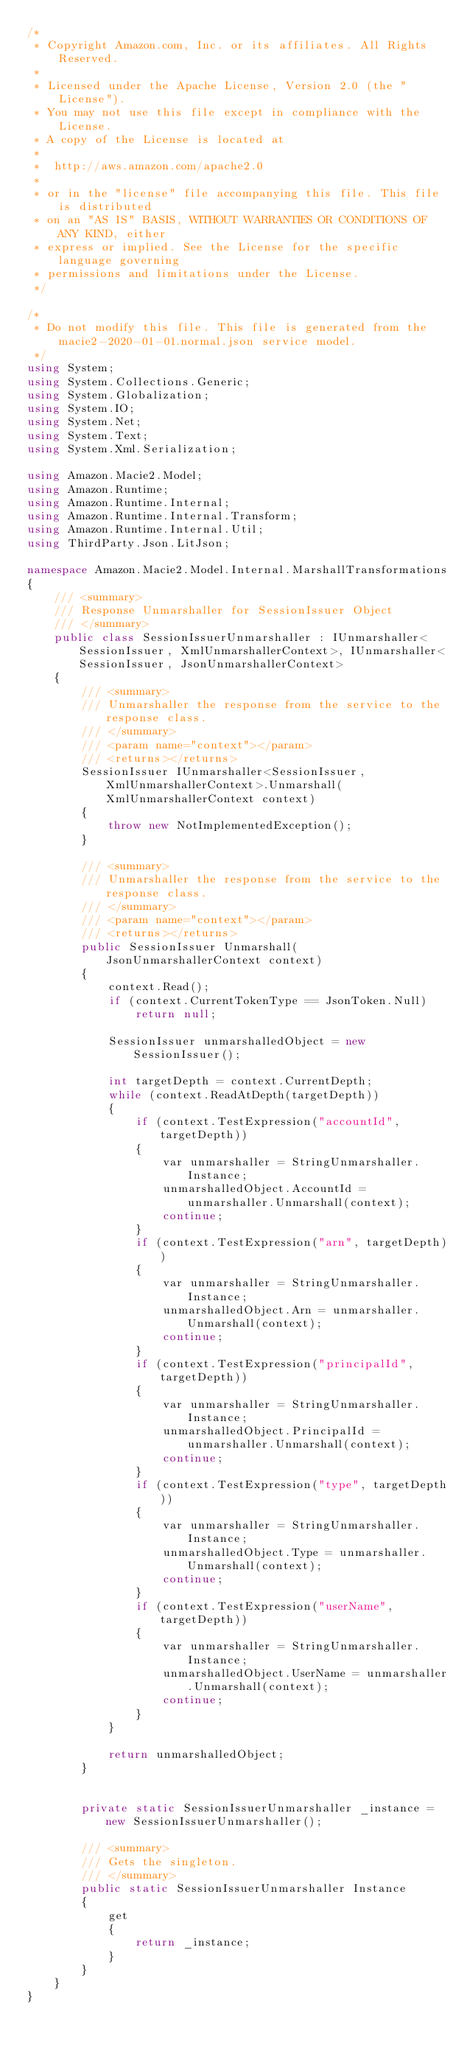<code> <loc_0><loc_0><loc_500><loc_500><_C#_>/*
 * Copyright Amazon.com, Inc. or its affiliates. All Rights Reserved.
 * 
 * Licensed under the Apache License, Version 2.0 (the "License").
 * You may not use this file except in compliance with the License.
 * A copy of the License is located at
 * 
 *  http://aws.amazon.com/apache2.0
 * 
 * or in the "license" file accompanying this file. This file is distributed
 * on an "AS IS" BASIS, WITHOUT WARRANTIES OR CONDITIONS OF ANY KIND, either
 * express or implied. See the License for the specific language governing
 * permissions and limitations under the License.
 */

/*
 * Do not modify this file. This file is generated from the macie2-2020-01-01.normal.json service model.
 */
using System;
using System.Collections.Generic;
using System.Globalization;
using System.IO;
using System.Net;
using System.Text;
using System.Xml.Serialization;

using Amazon.Macie2.Model;
using Amazon.Runtime;
using Amazon.Runtime.Internal;
using Amazon.Runtime.Internal.Transform;
using Amazon.Runtime.Internal.Util;
using ThirdParty.Json.LitJson;

namespace Amazon.Macie2.Model.Internal.MarshallTransformations
{
    /// <summary>
    /// Response Unmarshaller for SessionIssuer Object
    /// </summary>  
    public class SessionIssuerUnmarshaller : IUnmarshaller<SessionIssuer, XmlUnmarshallerContext>, IUnmarshaller<SessionIssuer, JsonUnmarshallerContext>
    {
        /// <summary>
        /// Unmarshaller the response from the service to the response class.
        /// </summary>  
        /// <param name="context"></param>
        /// <returns></returns>
        SessionIssuer IUnmarshaller<SessionIssuer, XmlUnmarshallerContext>.Unmarshall(XmlUnmarshallerContext context)
        {
            throw new NotImplementedException();
        }

        /// <summary>
        /// Unmarshaller the response from the service to the response class.
        /// </summary>  
        /// <param name="context"></param>
        /// <returns></returns>
        public SessionIssuer Unmarshall(JsonUnmarshallerContext context)
        {
            context.Read();
            if (context.CurrentTokenType == JsonToken.Null) 
                return null;

            SessionIssuer unmarshalledObject = new SessionIssuer();
        
            int targetDepth = context.CurrentDepth;
            while (context.ReadAtDepth(targetDepth))
            {
                if (context.TestExpression("accountId", targetDepth))
                {
                    var unmarshaller = StringUnmarshaller.Instance;
                    unmarshalledObject.AccountId = unmarshaller.Unmarshall(context);
                    continue;
                }
                if (context.TestExpression("arn", targetDepth))
                {
                    var unmarshaller = StringUnmarshaller.Instance;
                    unmarshalledObject.Arn = unmarshaller.Unmarshall(context);
                    continue;
                }
                if (context.TestExpression("principalId", targetDepth))
                {
                    var unmarshaller = StringUnmarshaller.Instance;
                    unmarshalledObject.PrincipalId = unmarshaller.Unmarshall(context);
                    continue;
                }
                if (context.TestExpression("type", targetDepth))
                {
                    var unmarshaller = StringUnmarshaller.Instance;
                    unmarshalledObject.Type = unmarshaller.Unmarshall(context);
                    continue;
                }
                if (context.TestExpression("userName", targetDepth))
                {
                    var unmarshaller = StringUnmarshaller.Instance;
                    unmarshalledObject.UserName = unmarshaller.Unmarshall(context);
                    continue;
                }
            }
          
            return unmarshalledObject;
        }


        private static SessionIssuerUnmarshaller _instance = new SessionIssuerUnmarshaller();        

        /// <summary>
        /// Gets the singleton.
        /// </summary>  
        public static SessionIssuerUnmarshaller Instance
        {
            get
            {
                return _instance;
            }
        }
    }
}</code> 